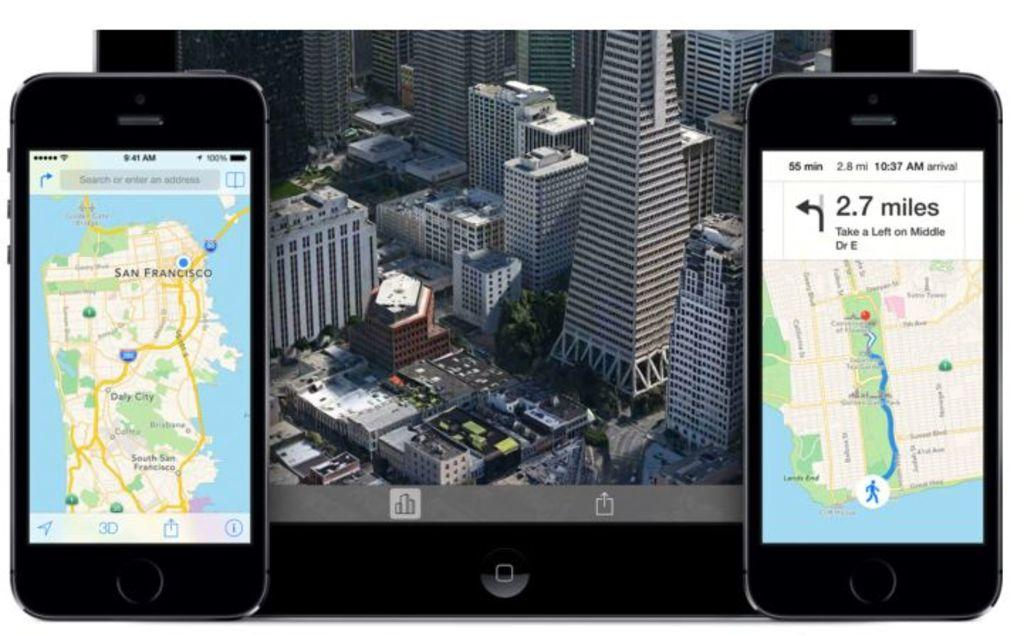<image>
Relay a brief, clear account of the picture shown. Screen of a phone showing directions to an area which takes 2.7 miles. 